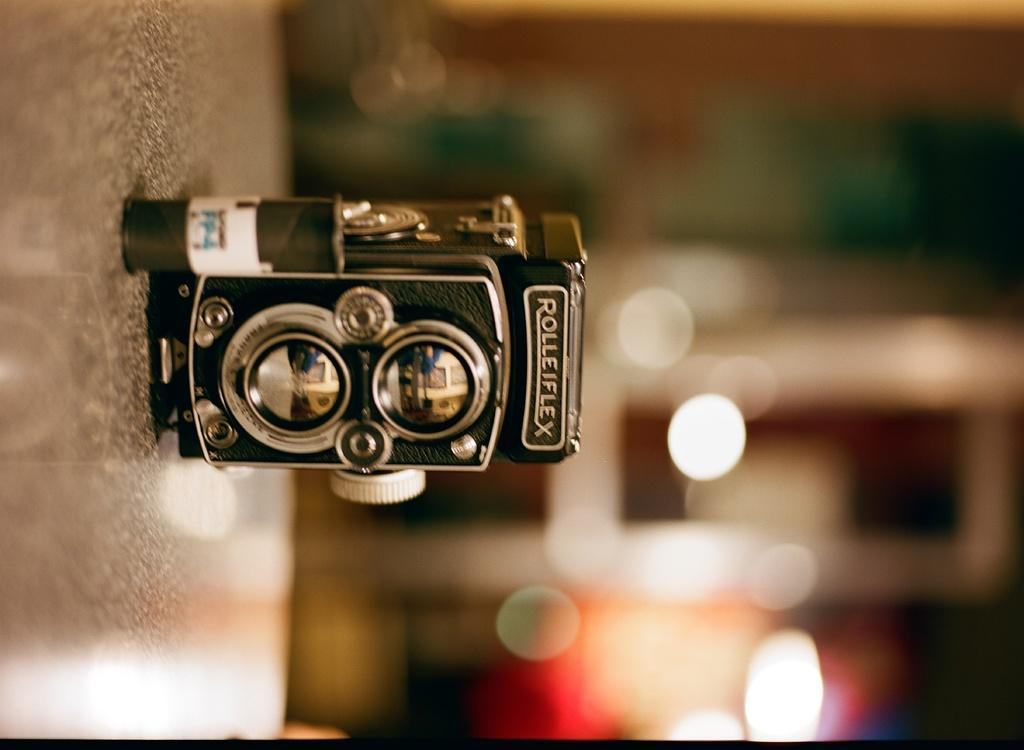Describe this image in one or two sentences. In the picture I can see camera placed on the surface, back side we can see light focuses. 